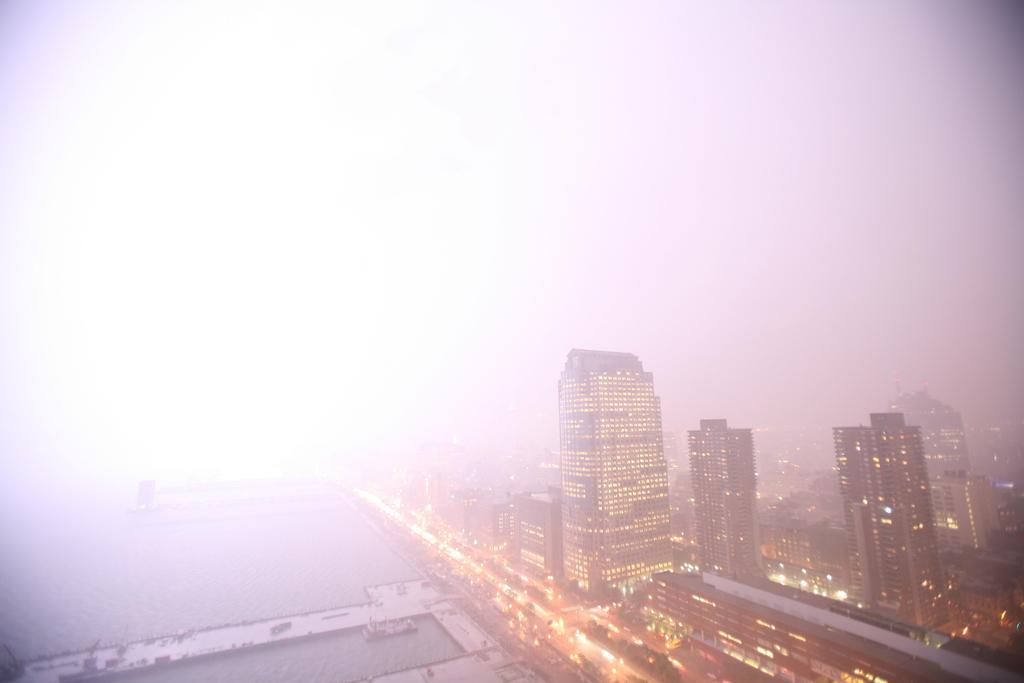How would you summarize this image in a sentence or two? This image consists of buildings and skyscrapers. On the left, we can see the water. At the top, there is sky. And the background is blurred. It looks like a smoke. 